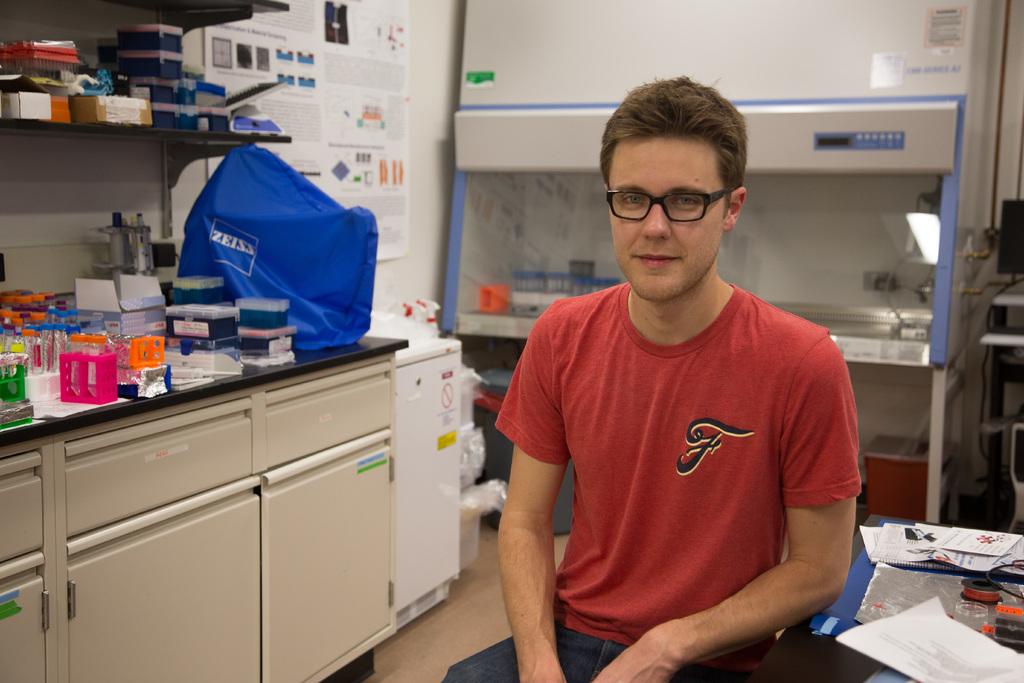What is on his shirt?
Your answer should be compact. F. What is written on the blue bag?
Offer a terse response. Zeiss. 